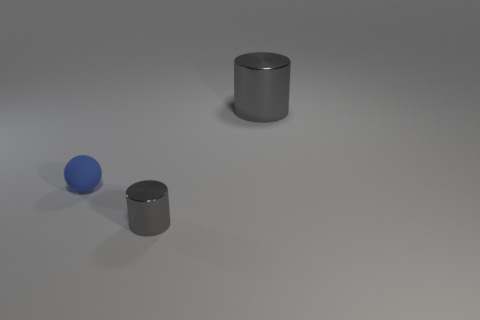There is a thing in front of the blue ball; does it have the same color as the big thing?
Your answer should be compact. Yes. What is the size of the other shiny thing that is the same color as the big object?
Offer a very short reply. Small. What is the large object right of the tiny blue ball made of?
Your answer should be compact. Metal. Is the material of the sphere left of the big shiny thing the same as the cylinder that is on the left side of the large thing?
Keep it short and to the point. No. Is the number of blue rubber objects that are on the right side of the small blue thing the same as the number of small gray cylinders that are left of the tiny gray cylinder?
Your answer should be very brief. Yes. How many other small spheres have the same material as the small blue ball?
Ensure brevity in your answer.  0. The other shiny thing that is the same color as the big object is what shape?
Offer a terse response. Cylinder. There is a gray object that is to the right of the metallic object in front of the big gray shiny thing; what is its size?
Ensure brevity in your answer.  Large. Does the gray thing behind the tiny rubber thing have the same shape as the shiny thing that is left of the large gray object?
Keep it short and to the point. Yes. Is the number of tiny gray metallic things that are right of the small gray metal cylinder the same as the number of tiny cylinders?
Your response must be concise. No. 